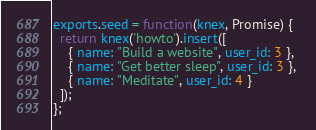Convert code to text. <code><loc_0><loc_0><loc_500><loc_500><_JavaScript_>
exports.seed = function(knex, Promise) {
  return knex('howto').insert([
    { name: "Build a website", user_id: 3 }, 
    { name: "Get better sleep", user_id: 3 }, 
    { name: "Meditate", user_id: 4 }
  ]);
};
</code> 